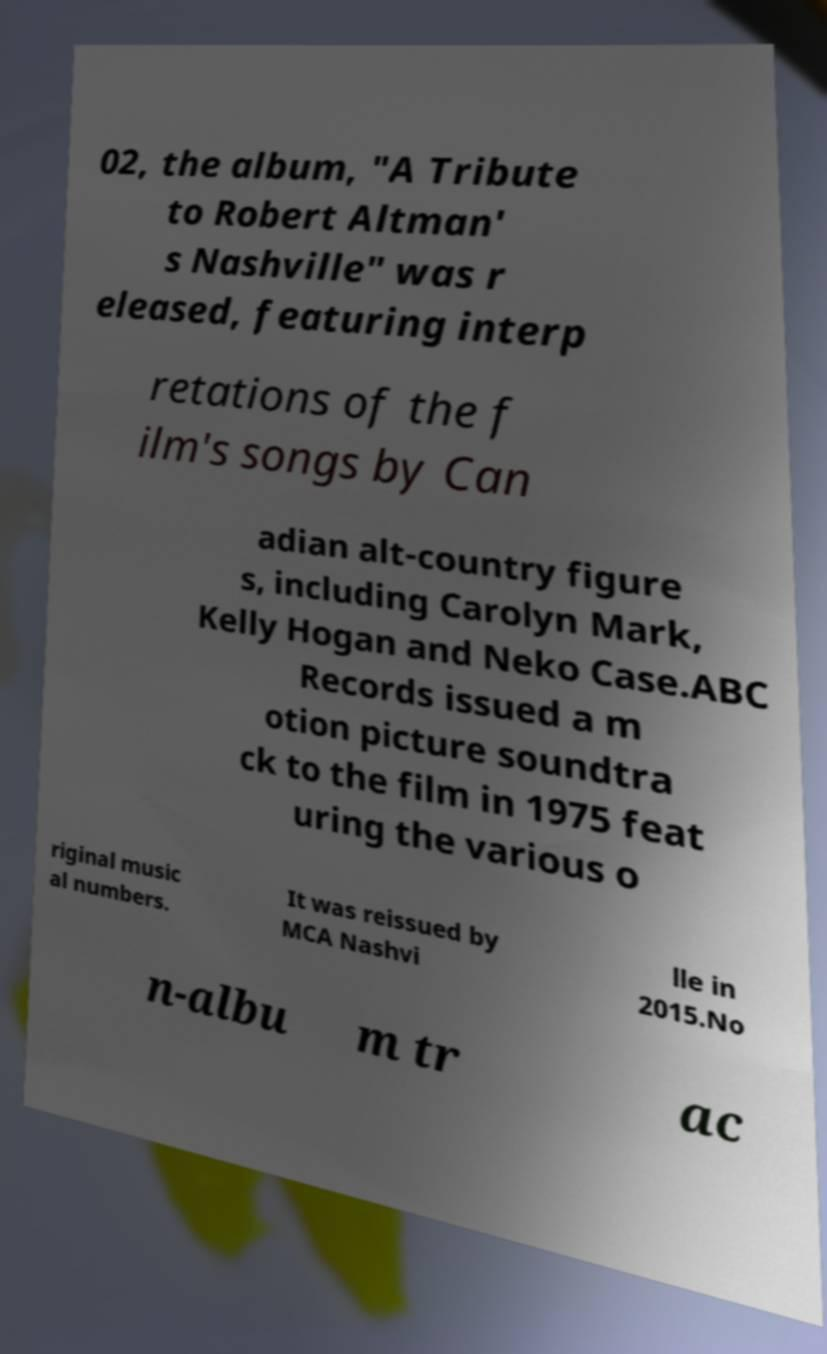Can you accurately transcribe the text from the provided image for me? 02, the album, "A Tribute to Robert Altman' s Nashville" was r eleased, featuring interp retations of the f ilm's songs by Can adian alt-country figure s, including Carolyn Mark, Kelly Hogan and Neko Case.ABC Records issued a m otion picture soundtra ck to the film in 1975 feat uring the various o riginal music al numbers. It was reissued by MCA Nashvi lle in 2015.No n-albu m tr ac 